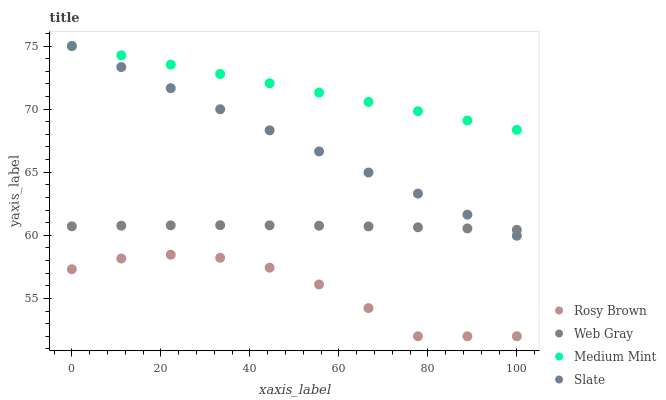Does Rosy Brown have the minimum area under the curve?
Answer yes or no. Yes. Does Medium Mint have the maximum area under the curve?
Answer yes or no. Yes. Does Slate have the minimum area under the curve?
Answer yes or no. No. Does Slate have the maximum area under the curve?
Answer yes or no. No. Is Medium Mint the smoothest?
Answer yes or no. Yes. Is Rosy Brown the roughest?
Answer yes or no. Yes. Is Slate the smoothest?
Answer yes or no. No. Is Slate the roughest?
Answer yes or no. No. Does Rosy Brown have the lowest value?
Answer yes or no. Yes. Does Slate have the lowest value?
Answer yes or no. No. Does Slate have the highest value?
Answer yes or no. Yes. Does Rosy Brown have the highest value?
Answer yes or no. No. Is Web Gray less than Medium Mint?
Answer yes or no. Yes. Is Medium Mint greater than Rosy Brown?
Answer yes or no. Yes. Does Slate intersect Web Gray?
Answer yes or no. Yes. Is Slate less than Web Gray?
Answer yes or no. No. Is Slate greater than Web Gray?
Answer yes or no. No. Does Web Gray intersect Medium Mint?
Answer yes or no. No. 